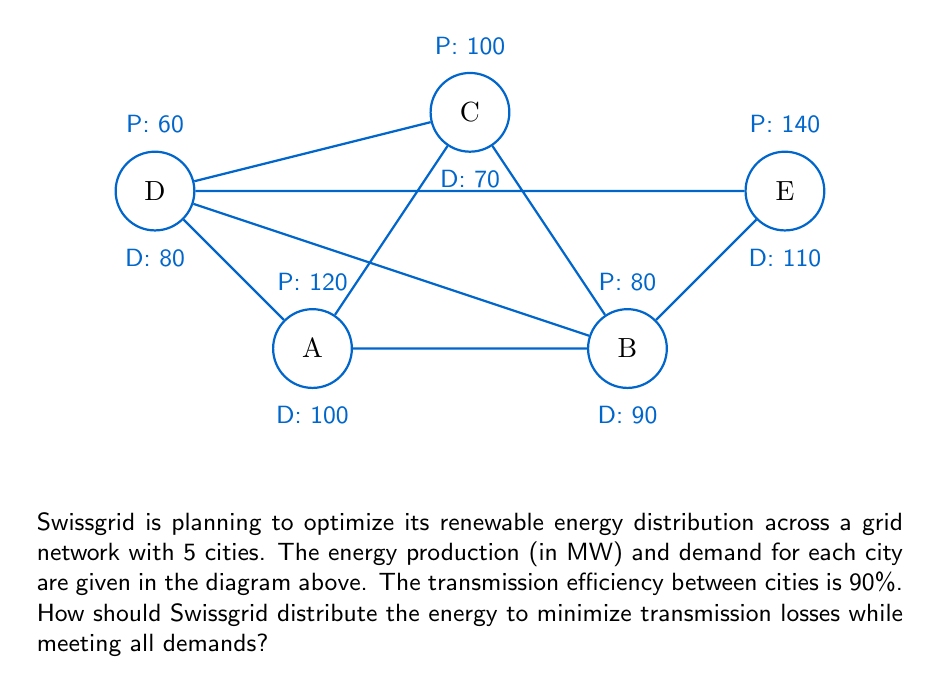Could you help me with this problem? To solve this optimization problem, we'll use the following steps:

1) Calculate the total production and demand:
   Total production = 120 + 80 + 100 + 60 + 140 = 500 MW
   Total demand = 100 + 90 + 70 + 80 + 110 = 450 MW

2) Identify cities with surplus and deficit:
   A: Surplus of 20 MW
   B: Deficit of 10 MW
   C: Surplus of 30 MW
   D: Deficit of 20 MW
   E: Surplus of 30 MW

3) To minimize transmission losses, we should prioritize local consumption and then distribute surplus to nearby cities.

4) Optimize the distribution:
   - A uses 100 MW locally, has 20 MW surplus
   - B uses 80 MW locally, needs 10 MW
   - C uses 70 MW locally, has 30 MW surplus
   - D uses 60 MW locally, needs 20 MW
   - E uses 110 MW locally, has 30 MW surplus

5) Distribute surplus:
   - A sends 10 MW to B (11.11 MW sent, 1.11 MW lost in transmission)
   - C sends 22.22 MW to D (24.69 MW sent, 2.47 MW lost in transmission)
   - E sends 10 MW to B (11.11 MW sent, 1.11 MW lost in transmission)

6) Calculate total transmission loss:
   Total loss = 1.11 + 2.47 + 1.11 = 4.69 MW

This distribution minimizes transmission losses while meeting all demands.
Answer: A→B: 11.11 MW, C→D: 24.69 MW, E→B: 11.11 MW; Total loss: 4.69 MW 